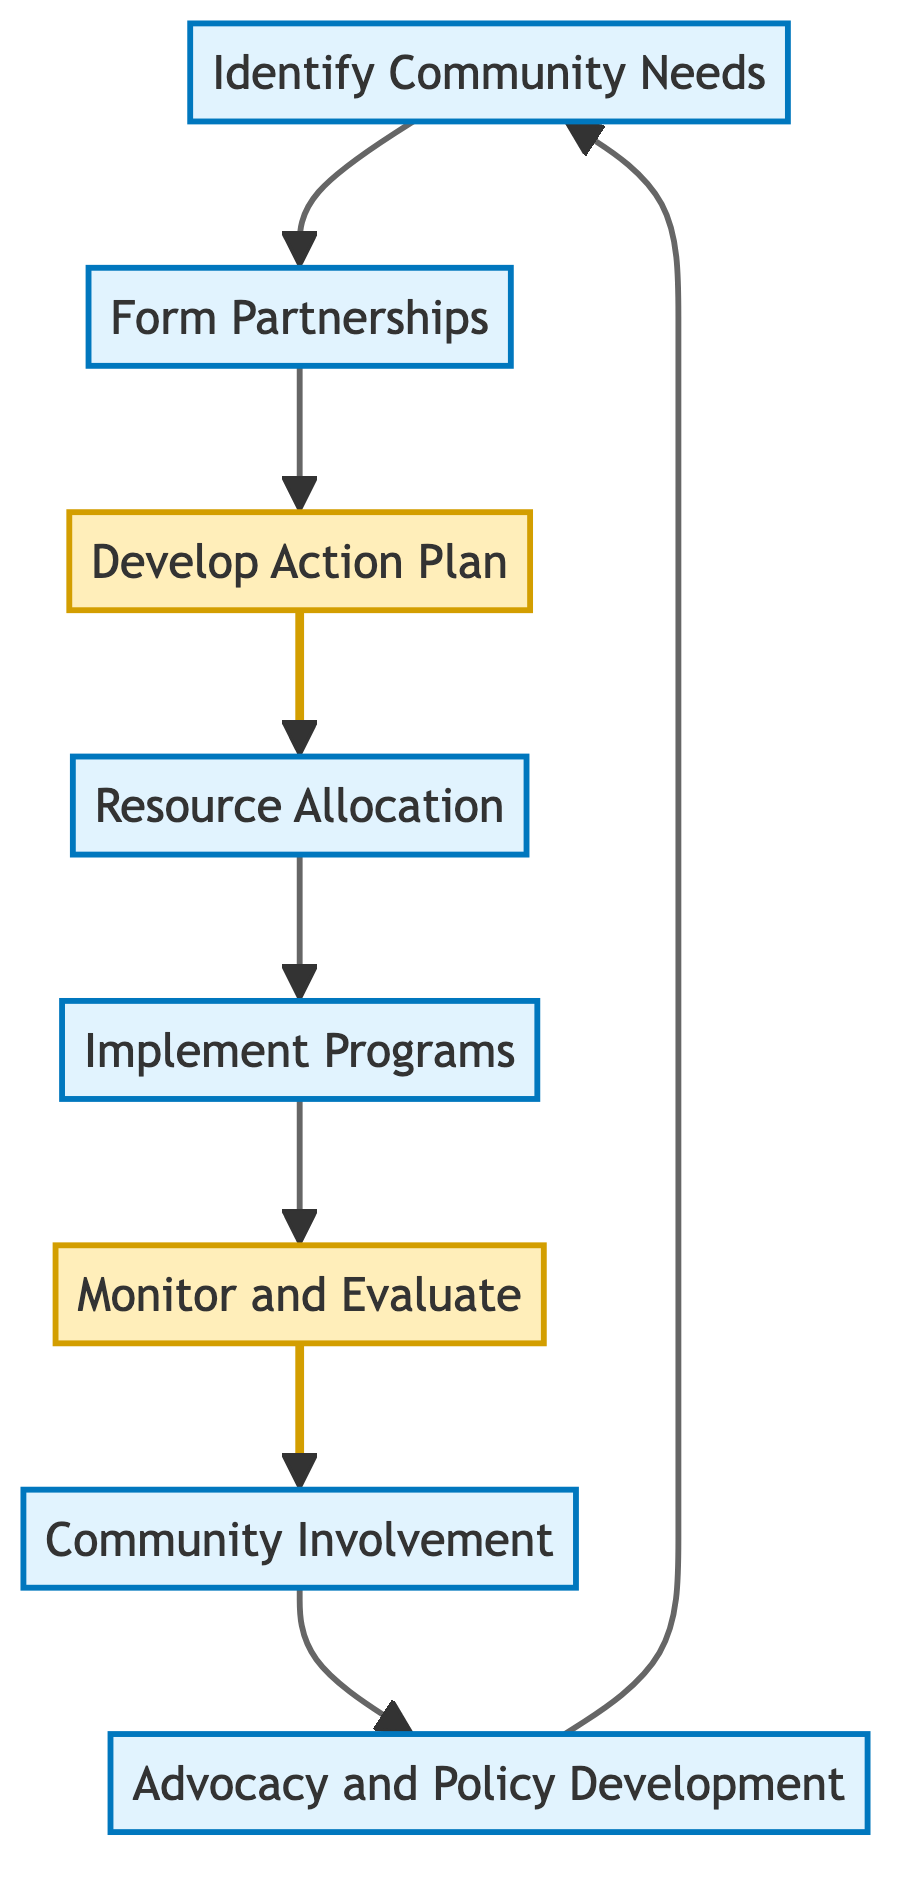What is the first step in the collaboration process? The diagram starts with the "Identify Community Needs" node, indicating it is the initial step in the collaboration process.
Answer: Identify Community Needs How many total nodes are present in the diagram? Counting all the unique elements in the diagram, there are eight distinct nodes representing different steps in the collaboration process.
Answer: Eight What comes after "Develop Action Plan"? The flow from "Develop Action Plan" directly connects to "Resource Allocation," indicating that resource allocation follows this action plan development step in the process.
Answer: Resource Allocation Which node represents the advocacy efforts? The final node "Advocacy and Policy Development" focuses on advocating for policy changes to support immigrant education initiatives.
Answer: Advocacy and Policy Development Is "Monitor and Evaluate" a decision node or a process node? According to the diagram, "Monitor and Evaluate" is marked as a decision node, which indicates it involves assessing outcomes and making adjustments.
Answer: Decision What are the last two steps before the advocacy efforts? Before reaching "Advocacy and Policy Development," the last two steps in the flow are "Community Involvement" and "Monitor and Evaluate," indicating that community support is integrated before advocacy.
Answer: Community Involvement, Monitor and Evaluate What type of organization partnerships are formed in this process? The diagram indicates that partnerships are formed with local non-profits, cultural associations, and immigrant advocacy groups, which are specifically mentioned in the "Form Partnerships" node.
Answer: Local non-profits, cultural associations, immigrant advocacy groups Which step involves the allocation of resources? The "Resource Allocation" node directly follows the "Develop Action Plan" node, clearly indicating that this step is where resources are allocated for supporting immigrant students.
Answer: Resource Allocation How does "Community Involvement" relate to the overall process? "Community Involvement" is a process step that engages the broader community to support immigrant students, which is crucial for fostering collaboration and resources beyond the school.
Answer: Engage broader community 